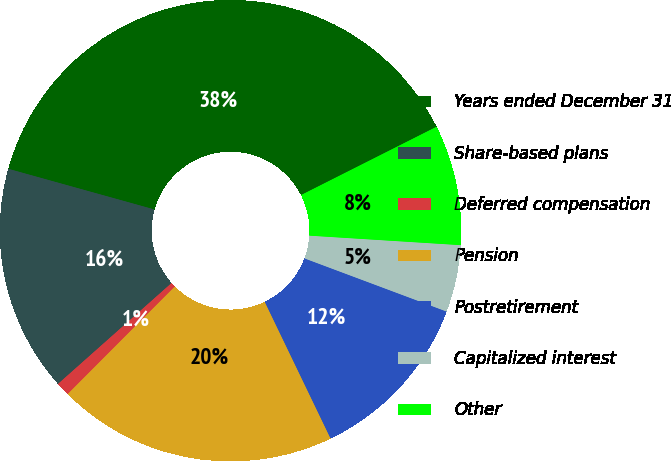<chart> <loc_0><loc_0><loc_500><loc_500><pie_chart><fcel>Years ended December 31<fcel>Share-based plans<fcel>Deferred compensation<fcel>Pension<fcel>Postretirement<fcel>Capitalized interest<fcel>Other<nl><fcel>38.25%<fcel>15.88%<fcel>0.97%<fcel>19.61%<fcel>12.16%<fcel>4.7%<fcel>8.43%<nl></chart> 